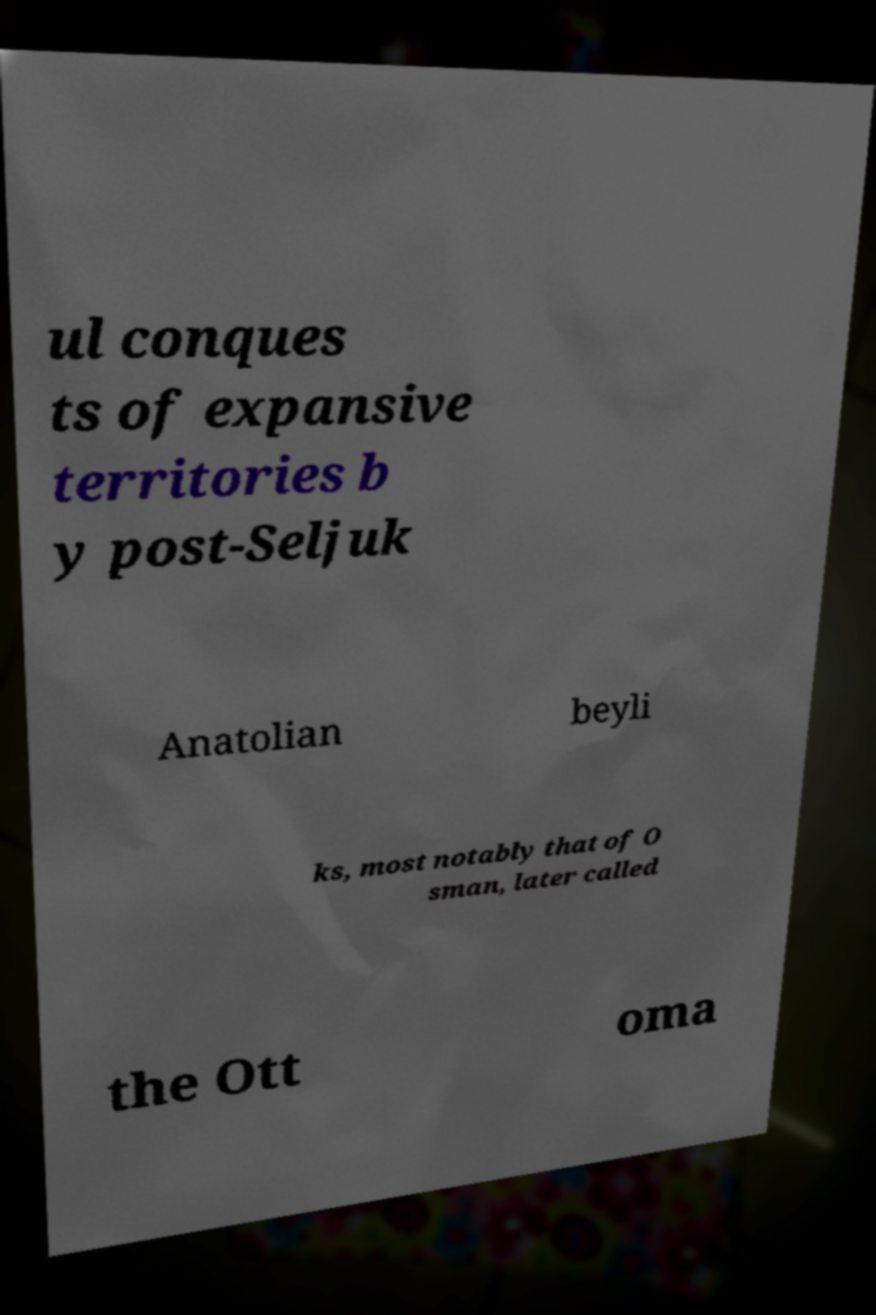What messages or text are displayed in this image? I need them in a readable, typed format. ul conques ts of expansive territories b y post-Seljuk Anatolian beyli ks, most notably that of O sman, later called the Ott oma 